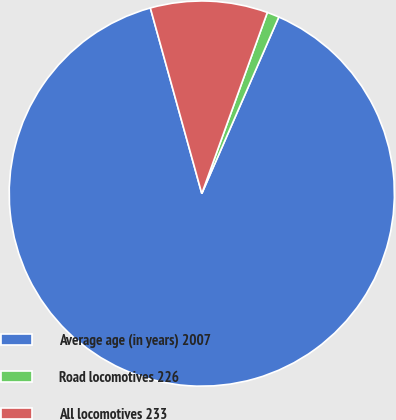Convert chart to OTSL. <chart><loc_0><loc_0><loc_500><loc_500><pie_chart><fcel>Average age (in years) 2007<fcel>Road locomotives 226<fcel>All locomotives 233<nl><fcel>89.15%<fcel>1.02%<fcel>9.83%<nl></chart> 